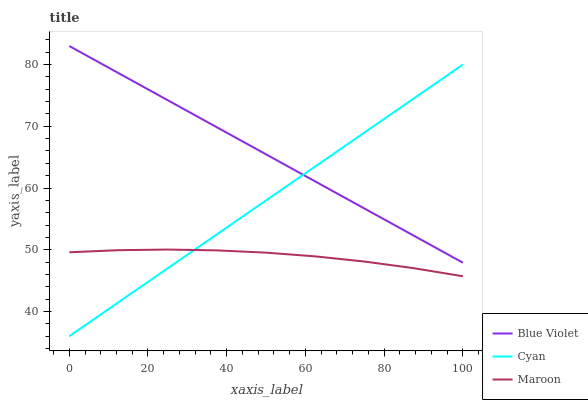Does Maroon have the minimum area under the curve?
Answer yes or no. Yes. Does Blue Violet have the maximum area under the curve?
Answer yes or no. Yes. Does Blue Violet have the minimum area under the curve?
Answer yes or no. No. Does Maroon have the maximum area under the curve?
Answer yes or no. No. Is Blue Violet the smoothest?
Answer yes or no. Yes. Is Maroon the roughest?
Answer yes or no. Yes. Is Maroon the smoothest?
Answer yes or no. No. Is Blue Violet the roughest?
Answer yes or no. No. Does Cyan have the lowest value?
Answer yes or no. Yes. Does Maroon have the lowest value?
Answer yes or no. No. Does Blue Violet have the highest value?
Answer yes or no. Yes. Does Maroon have the highest value?
Answer yes or no. No. Is Maroon less than Blue Violet?
Answer yes or no. Yes. Is Blue Violet greater than Maroon?
Answer yes or no. Yes. Does Cyan intersect Maroon?
Answer yes or no. Yes. Is Cyan less than Maroon?
Answer yes or no. No. Is Cyan greater than Maroon?
Answer yes or no. No. Does Maroon intersect Blue Violet?
Answer yes or no. No. 